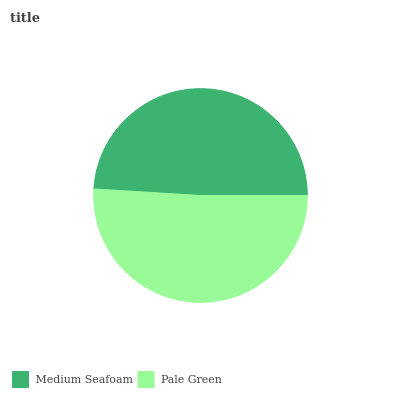Is Medium Seafoam the minimum?
Answer yes or no. Yes. Is Pale Green the maximum?
Answer yes or no. Yes. Is Pale Green the minimum?
Answer yes or no. No. Is Pale Green greater than Medium Seafoam?
Answer yes or no. Yes. Is Medium Seafoam less than Pale Green?
Answer yes or no. Yes. Is Medium Seafoam greater than Pale Green?
Answer yes or no. No. Is Pale Green less than Medium Seafoam?
Answer yes or no. No. Is Pale Green the high median?
Answer yes or no. Yes. Is Medium Seafoam the low median?
Answer yes or no. Yes. Is Medium Seafoam the high median?
Answer yes or no. No. Is Pale Green the low median?
Answer yes or no. No. 